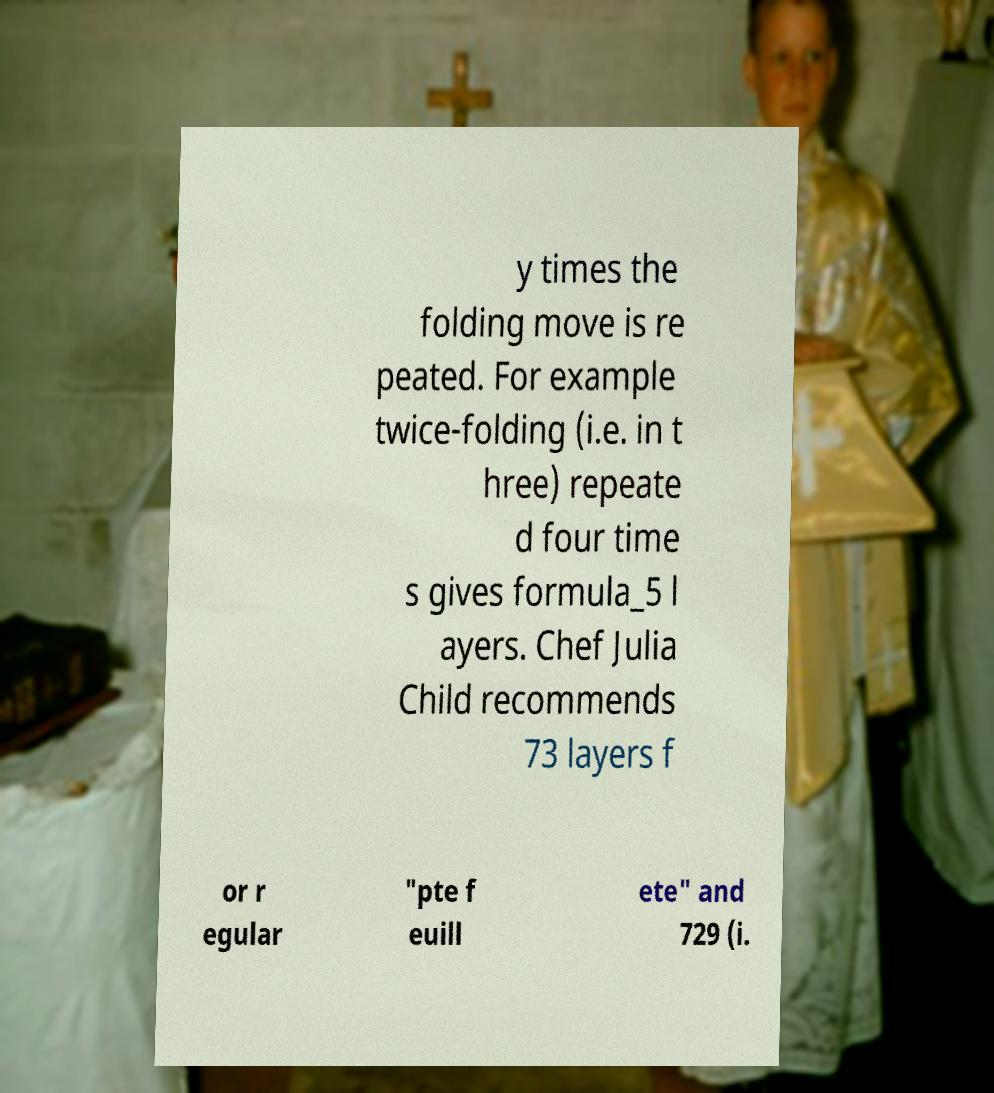Please identify and transcribe the text found in this image. y times the folding move is re peated. For example twice-folding (i.e. in t hree) repeate d four time s gives formula_5 l ayers. Chef Julia Child recommends 73 layers f or r egular "pte f euill ete" and 729 (i. 